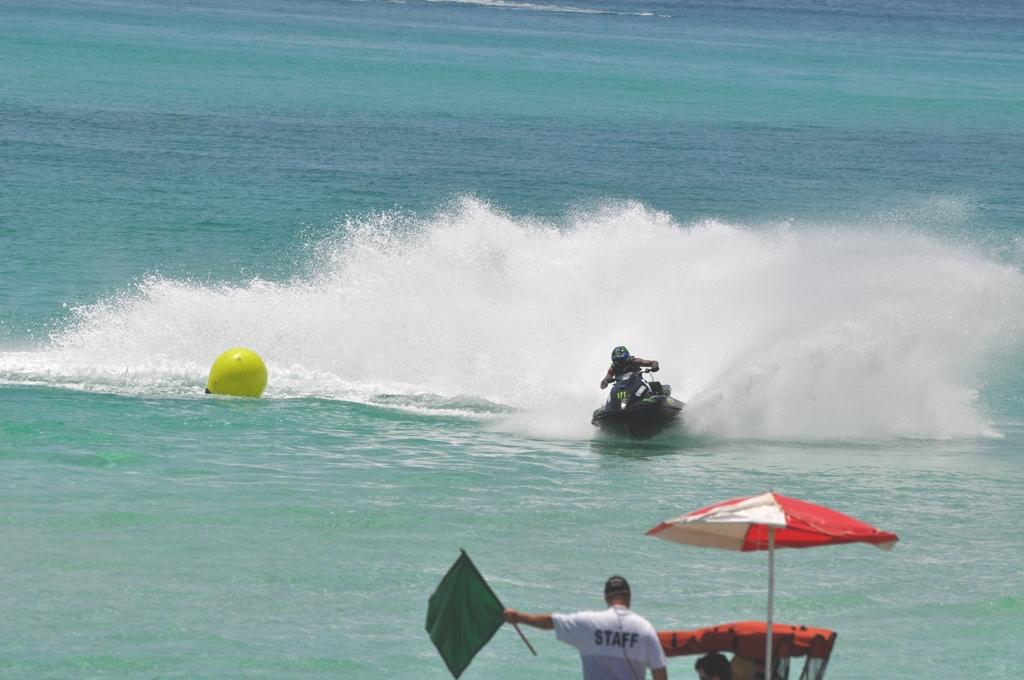Who is the main subject in the image? There is a person standing at the front in the image. What is the person holding? The person is holding a flag. What can be seen on the right side of the image? There is an umbrella on the right side of the image. What is the person in the background doing? A person is riding a speedboat in the image. Where is the speedboat located? The speedboat is on the water. What is the angle of the power lines in the image? There are no power lines present in the image. 